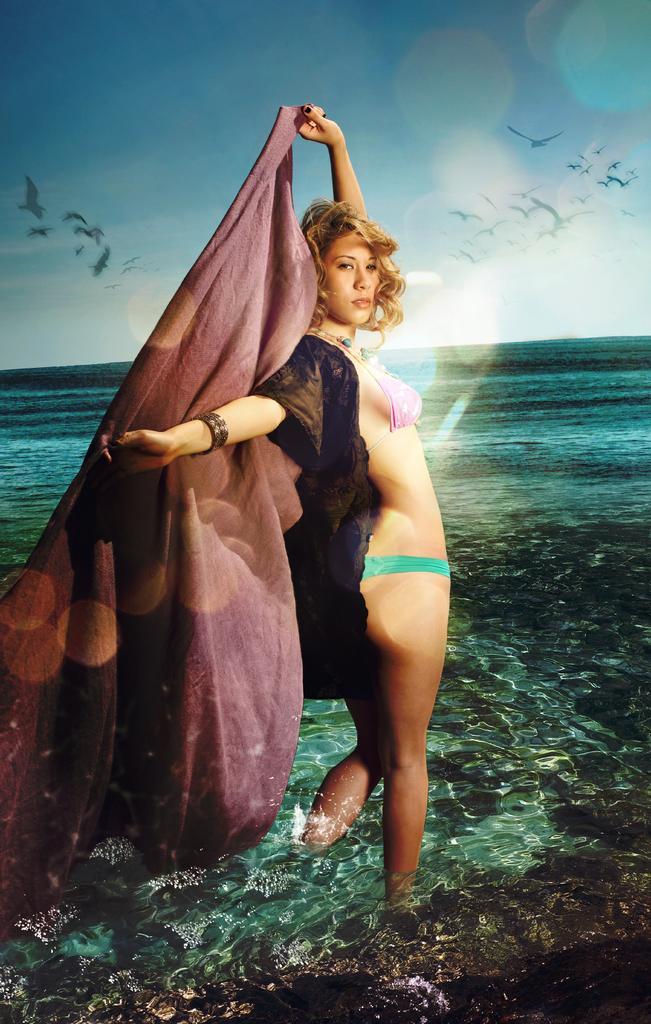Can you describe this image briefly? In the center of the image we can see one girl standing in the water. And she is holding a cloth, which is in brown color. And we can see she is in a different costume. In the background we can see the sky, water, few birds are flying and a few other objects. 